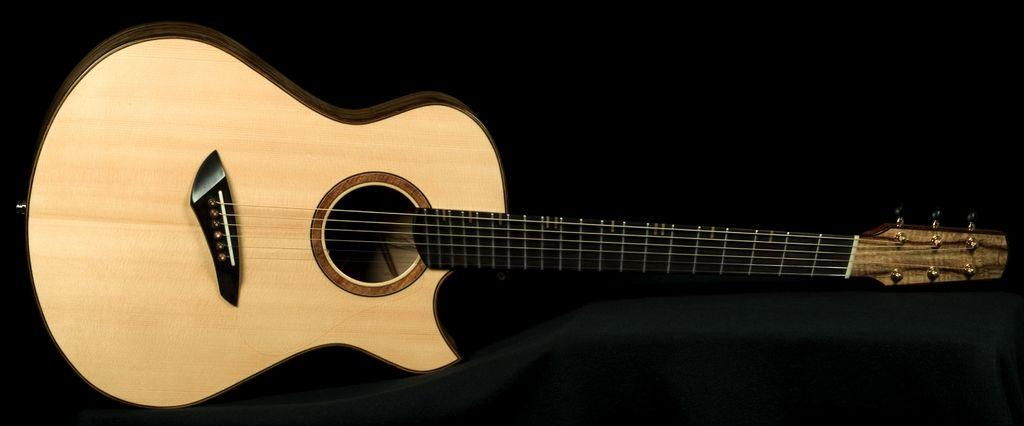What musical instrument is present in the image? There is a guitar in the image. How is the guitar positioned in the image? The guitar is placed inclined on a board. What color is the guitar in the image? The guitar is in snuff color. What type of jeans is the guitar wearing in the image? The guitar is an inanimate object and does not wear jeans. 